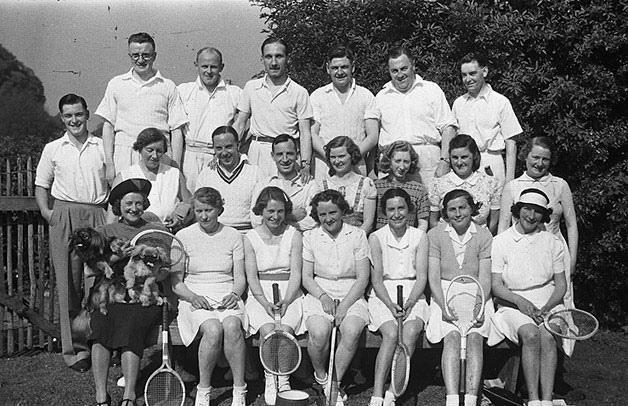How many countries are officially represented?
Give a very brief answer. 1. How many people are visible?
Give a very brief answer. 14. How many skateboards are laying down?
Give a very brief answer. 0. 